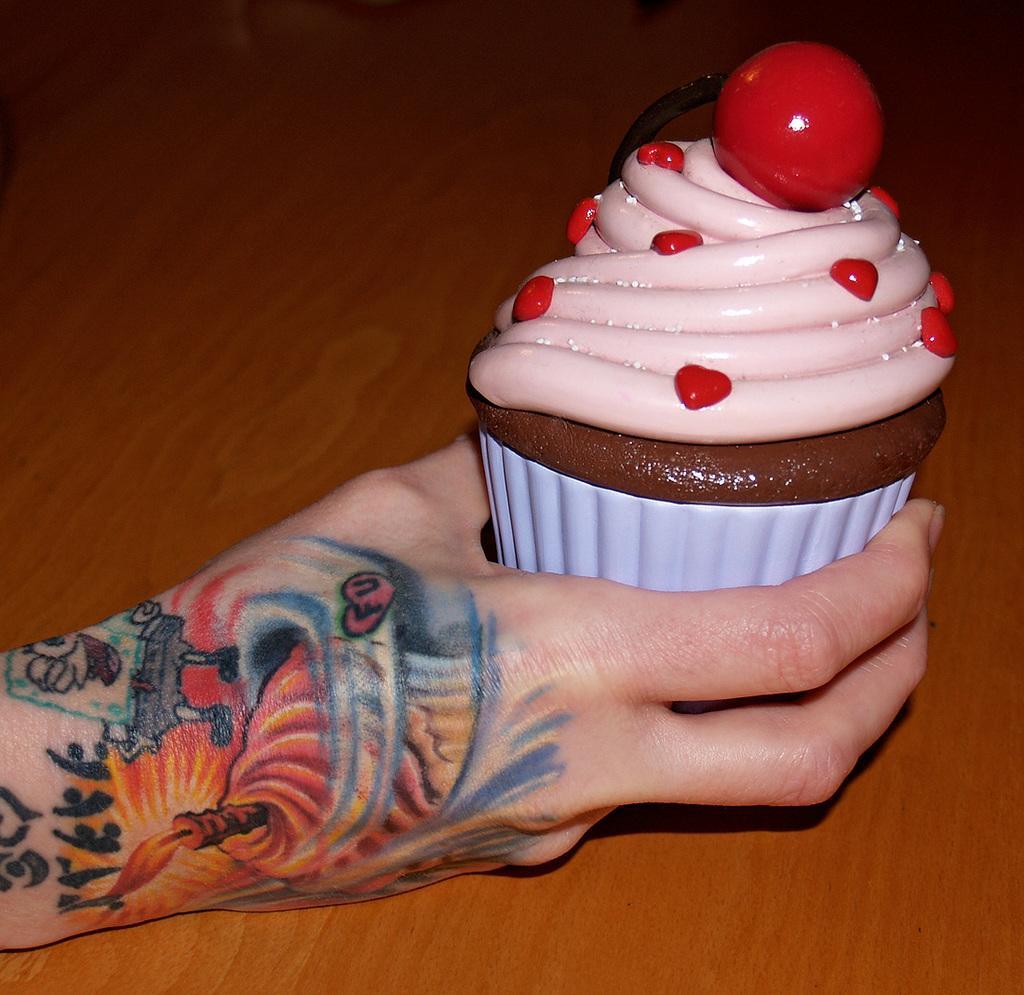In one or two sentences, can you explain what this image depicts? In this image I can see hand of a person is holding a cupcake. I can also see tattoos on the hand and in the background I can see brown colour surface. 